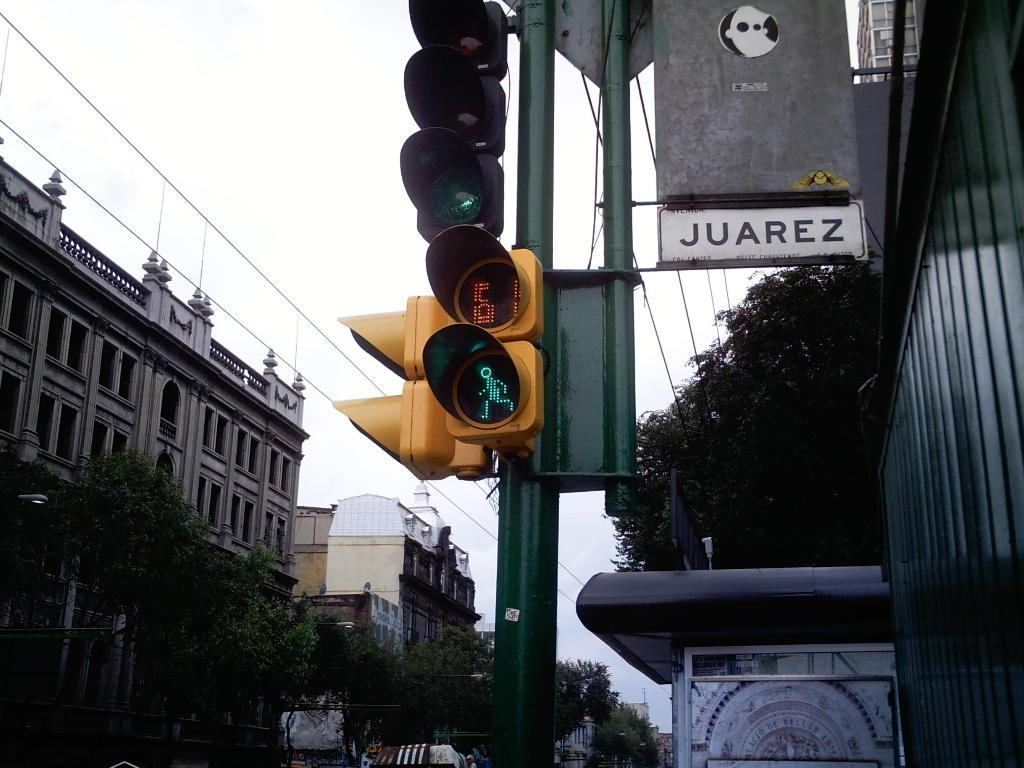<image>
Summarize the visual content of the image. a sign with Juarez on the side next to the light 